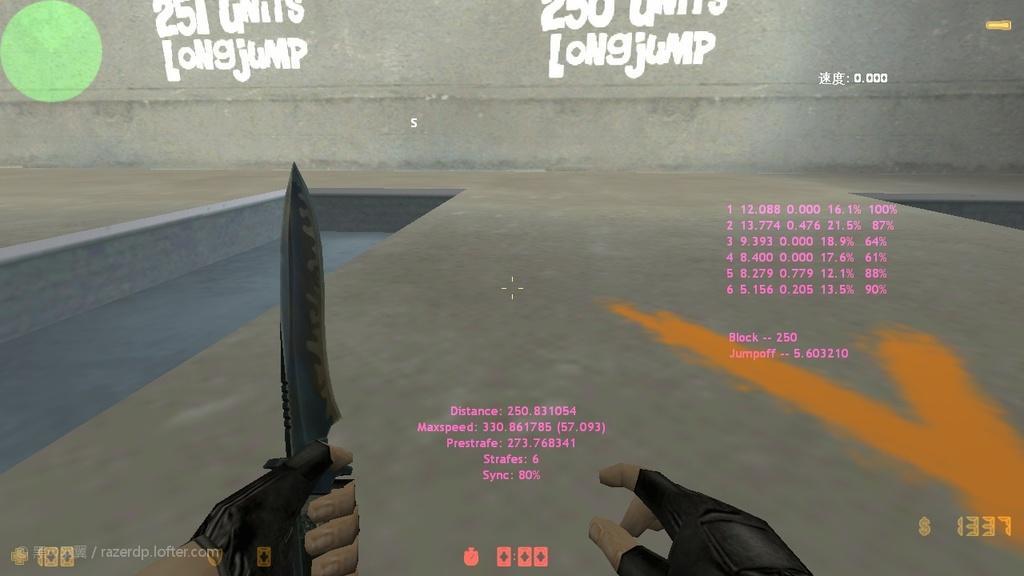How would you summarize this image in a sentence or two? In this picture we can observe graphics. There are two hands. In one of the hands we can observe a knife. There are some pink color words and numbers. In the background there is a wall on which we can observe a green color circle and some white color words. 